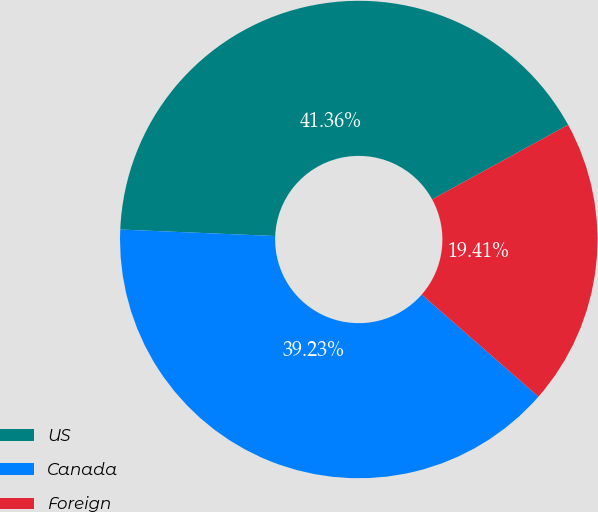Convert chart to OTSL. <chart><loc_0><loc_0><loc_500><loc_500><pie_chart><fcel>US<fcel>Canada<fcel>Foreign<nl><fcel>41.36%<fcel>39.23%<fcel>19.41%<nl></chart> 